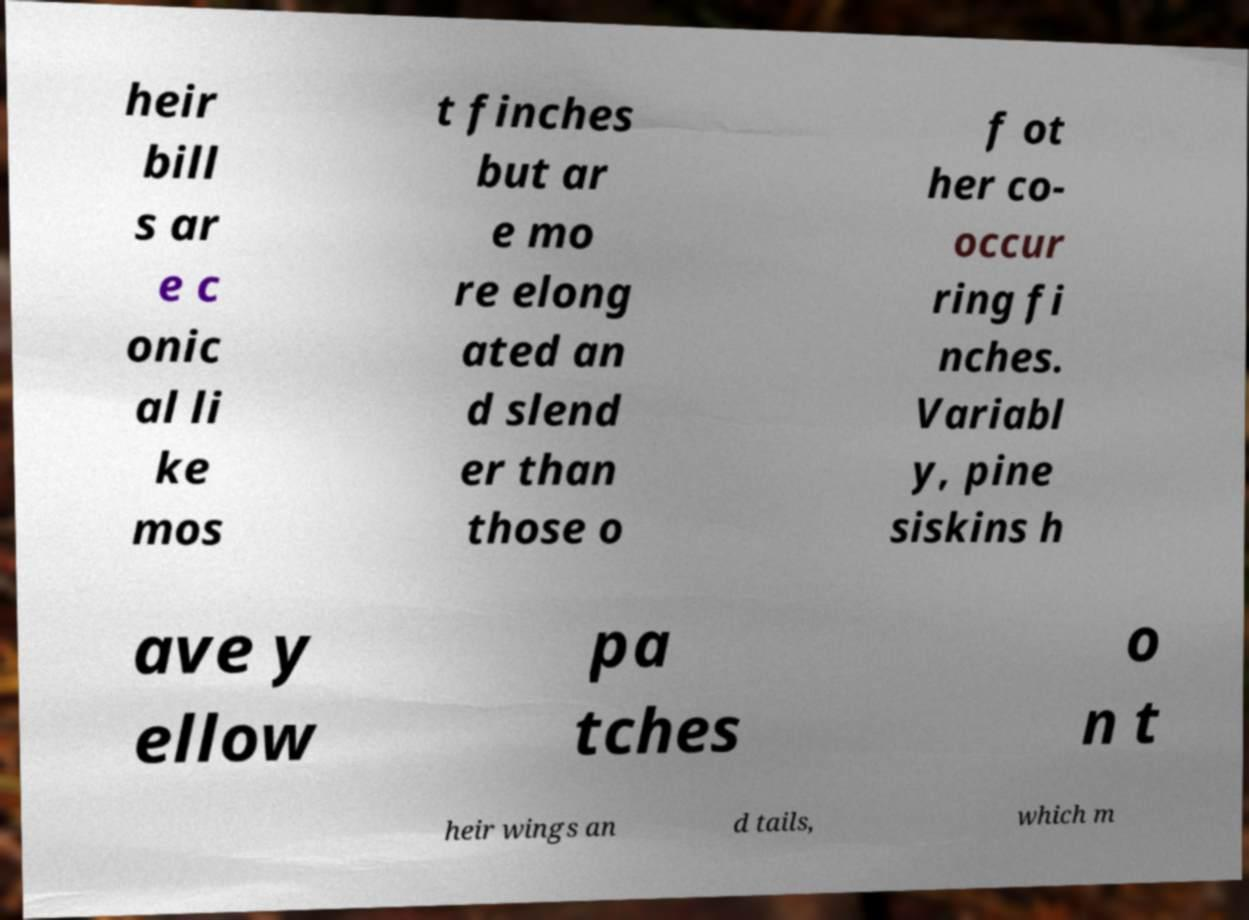Could you assist in decoding the text presented in this image and type it out clearly? heir bill s ar e c onic al li ke mos t finches but ar e mo re elong ated an d slend er than those o f ot her co- occur ring fi nches. Variabl y, pine siskins h ave y ellow pa tches o n t heir wings an d tails, which m 